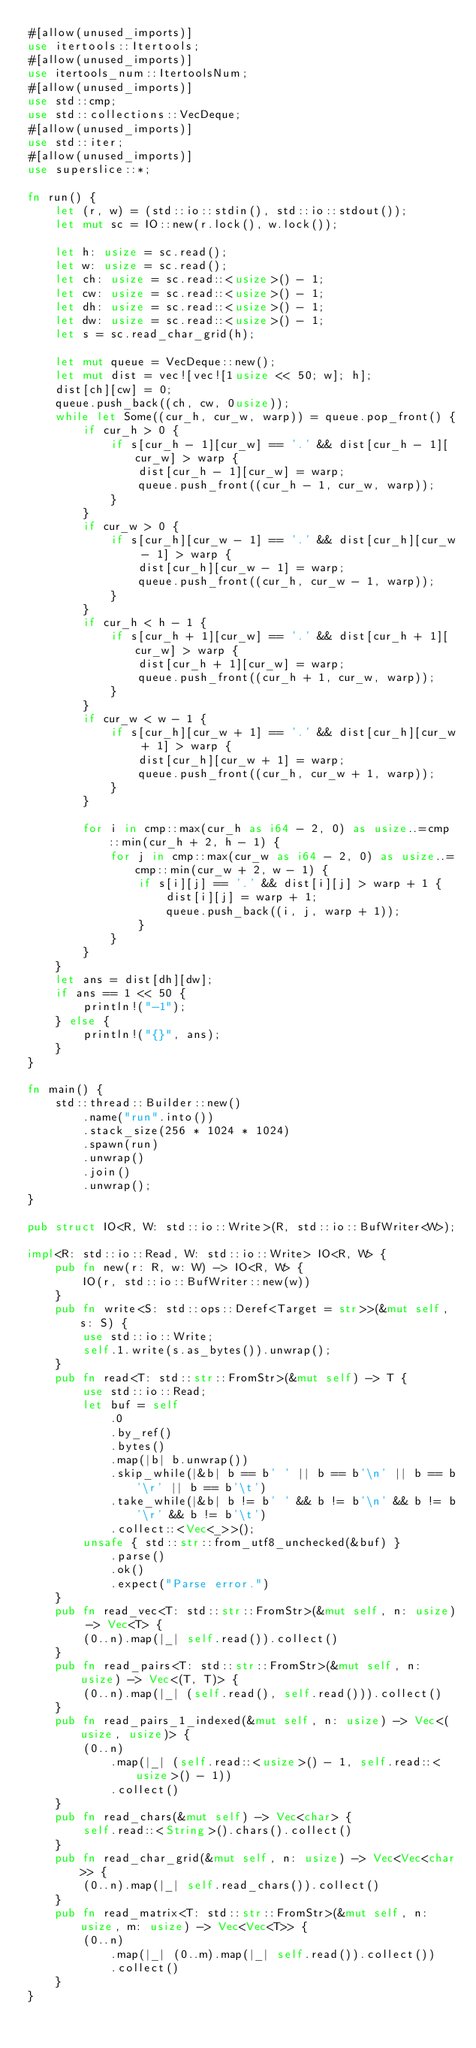Convert code to text. <code><loc_0><loc_0><loc_500><loc_500><_Rust_>#[allow(unused_imports)]
use itertools::Itertools;
#[allow(unused_imports)]
use itertools_num::ItertoolsNum;
#[allow(unused_imports)]
use std::cmp;
use std::collections::VecDeque;
#[allow(unused_imports)]
use std::iter;
#[allow(unused_imports)]
use superslice::*;

fn run() {
    let (r, w) = (std::io::stdin(), std::io::stdout());
    let mut sc = IO::new(r.lock(), w.lock());

    let h: usize = sc.read();
    let w: usize = sc.read();
    let ch: usize = sc.read::<usize>() - 1;
    let cw: usize = sc.read::<usize>() - 1;
    let dh: usize = sc.read::<usize>() - 1;
    let dw: usize = sc.read::<usize>() - 1;
    let s = sc.read_char_grid(h);

    let mut queue = VecDeque::new();
    let mut dist = vec![vec![1usize << 50; w]; h];
    dist[ch][cw] = 0;
    queue.push_back((ch, cw, 0usize));
    while let Some((cur_h, cur_w, warp)) = queue.pop_front() {
        if cur_h > 0 {
            if s[cur_h - 1][cur_w] == '.' && dist[cur_h - 1][cur_w] > warp {
                dist[cur_h - 1][cur_w] = warp;
                queue.push_front((cur_h - 1, cur_w, warp));
            }
        }
        if cur_w > 0 {
            if s[cur_h][cur_w - 1] == '.' && dist[cur_h][cur_w - 1] > warp {
                dist[cur_h][cur_w - 1] = warp;
                queue.push_front((cur_h, cur_w - 1, warp));
            }
        }
        if cur_h < h - 1 {
            if s[cur_h + 1][cur_w] == '.' && dist[cur_h + 1][cur_w] > warp {
                dist[cur_h + 1][cur_w] = warp;
                queue.push_front((cur_h + 1, cur_w, warp));
            }
        }
        if cur_w < w - 1 {
            if s[cur_h][cur_w + 1] == '.' && dist[cur_h][cur_w + 1] > warp {
                dist[cur_h][cur_w + 1] = warp;
                queue.push_front((cur_h, cur_w + 1, warp));
            }
        }

        for i in cmp::max(cur_h as i64 - 2, 0) as usize..=cmp::min(cur_h + 2, h - 1) {
            for j in cmp::max(cur_w as i64 - 2, 0) as usize..=cmp::min(cur_w + 2, w - 1) {
                if s[i][j] == '.' && dist[i][j] > warp + 1 {
                    dist[i][j] = warp + 1;
                    queue.push_back((i, j, warp + 1));
                }
            }
        }
    }
    let ans = dist[dh][dw];
    if ans == 1 << 50 {
        println!("-1");
    } else {
        println!("{}", ans);
    }
}

fn main() {
    std::thread::Builder::new()
        .name("run".into())
        .stack_size(256 * 1024 * 1024)
        .spawn(run)
        .unwrap()
        .join()
        .unwrap();
}

pub struct IO<R, W: std::io::Write>(R, std::io::BufWriter<W>);

impl<R: std::io::Read, W: std::io::Write> IO<R, W> {
    pub fn new(r: R, w: W) -> IO<R, W> {
        IO(r, std::io::BufWriter::new(w))
    }
    pub fn write<S: std::ops::Deref<Target = str>>(&mut self, s: S) {
        use std::io::Write;
        self.1.write(s.as_bytes()).unwrap();
    }
    pub fn read<T: std::str::FromStr>(&mut self) -> T {
        use std::io::Read;
        let buf = self
            .0
            .by_ref()
            .bytes()
            .map(|b| b.unwrap())
            .skip_while(|&b| b == b' ' || b == b'\n' || b == b'\r' || b == b'\t')
            .take_while(|&b| b != b' ' && b != b'\n' && b != b'\r' && b != b'\t')
            .collect::<Vec<_>>();
        unsafe { std::str::from_utf8_unchecked(&buf) }
            .parse()
            .ok()
            .expect("Parse error.")
    }
    pub fn read_vec<T: std::str::FromStr>(&mut self, n: usize) -> Vec<T> {
        (0..n).map(|_| self.read()).collect()
    }
    pub fn read_pairs<T: std::str::FromStr>(&mut self, n: usize) -> Vec<(T, T)> {
        (0..n).map(|_| (self.read(), self.read())).collect()
    }
    pub fn read_pairs_1_indexed(&mut self, n: usize) -> Vec<(usize, usize)> {
        (0..n)
            .map(|_| (self.read::<usize>() - 1, self.read::<usize>() - 1))
            .collect()
    }
    pub fn read_chars(&mut self) -> Vec<char> {
        self.read::<String>().chars().collect()
    }
    pub fn read_char_grid(&mut self, n: usize) -> Vec<Vec<char>> {
        (0..n).map(|_| self.read_chars()).collect()
    }
    pub fn read_matrix<T: std::str::FromStr>(&mut self, n: usize, m: usize) -> Vec<Vec<T>> {
        (0..n)
            .map(|_| (0..m).map(|_| self.read()).collect())
            .collect()
    }
}
</code> 